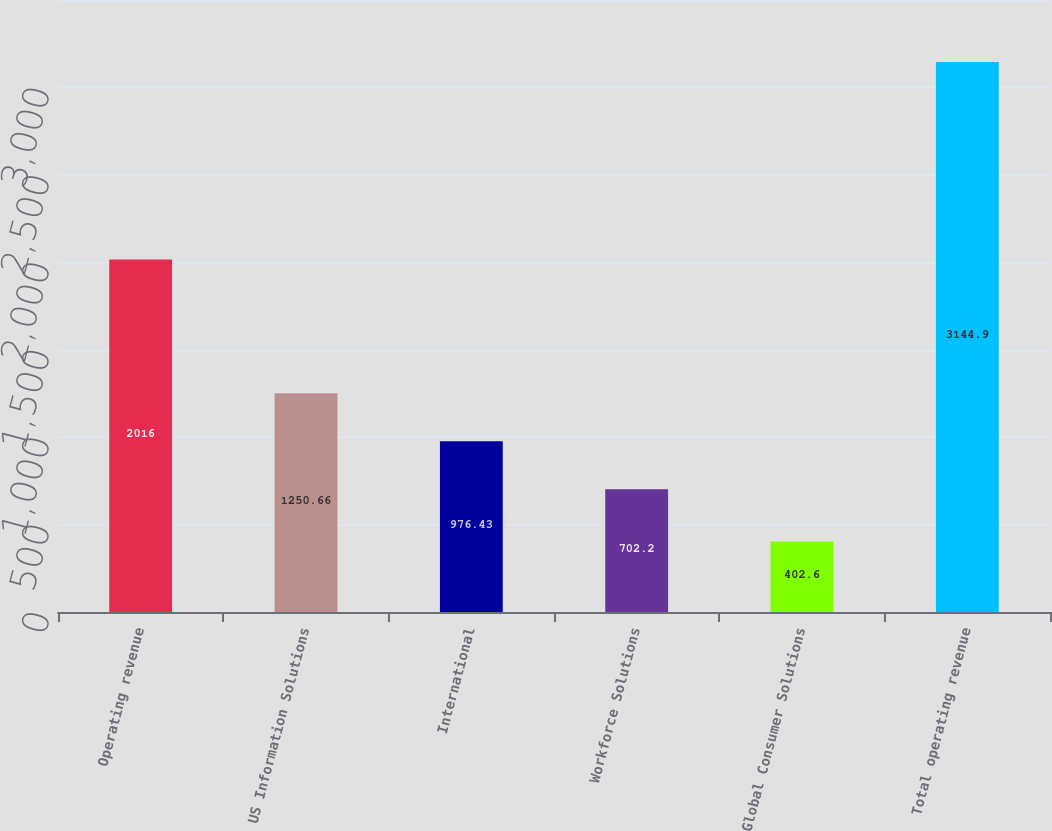Convert chart to OTSL. <chart><loc_0><loc_0><loc_500><loc_500><bar_chart><fcel>Operating revenue<fcel>US Information Solutions<fcel>International<fcel>Workforce Solutions<fcel>Global Consumer Solutions<fcel>Total operating revenue<nl><fcel>2016<fcel>1250.66<fcel>976.43<fcel>702.2<fcel>402.6<fcel>3144.9<nl></chart> 